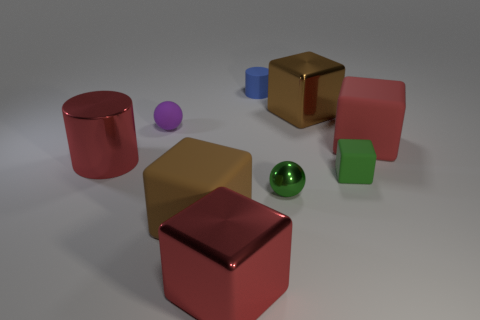What number of other things are the same material as the green ball?
Provide a succinct answer. 3. There is a green rubber thing; are there any small green cubes to the left of it?
Ensure brevity in your answer.  No. There is a red thing that is the same shape as the tiny blue matte object; what size is it?
Ensure brevity in your answer.  Large. Is the number of purple rubber things in front of the small purple sphere the same as the number of tiny metallic balls right of the large red matte thing?
Ensure brevity in your answer.  Yes. How many blue metallic blocks are there?
Keep it short and to the point. 0. Are there more green things in front of the tiny green block than large rubber things?
Keep it short and to the point. No. There is a large brown object that is in front of the small cube; what is it made of?
Provide a short and direct response. Rubber. What is the color of the other shiny object that is the same shape as the large brown metal thing?
Your answer should be very brief. Red. How many tiny things are the same color as the shiny cylinder?
Keep it short and to the point. 0. There is a ball in front of the small block; is its size the same as the metal thing behind the red matte block?
Your answer should be very brief. No. 